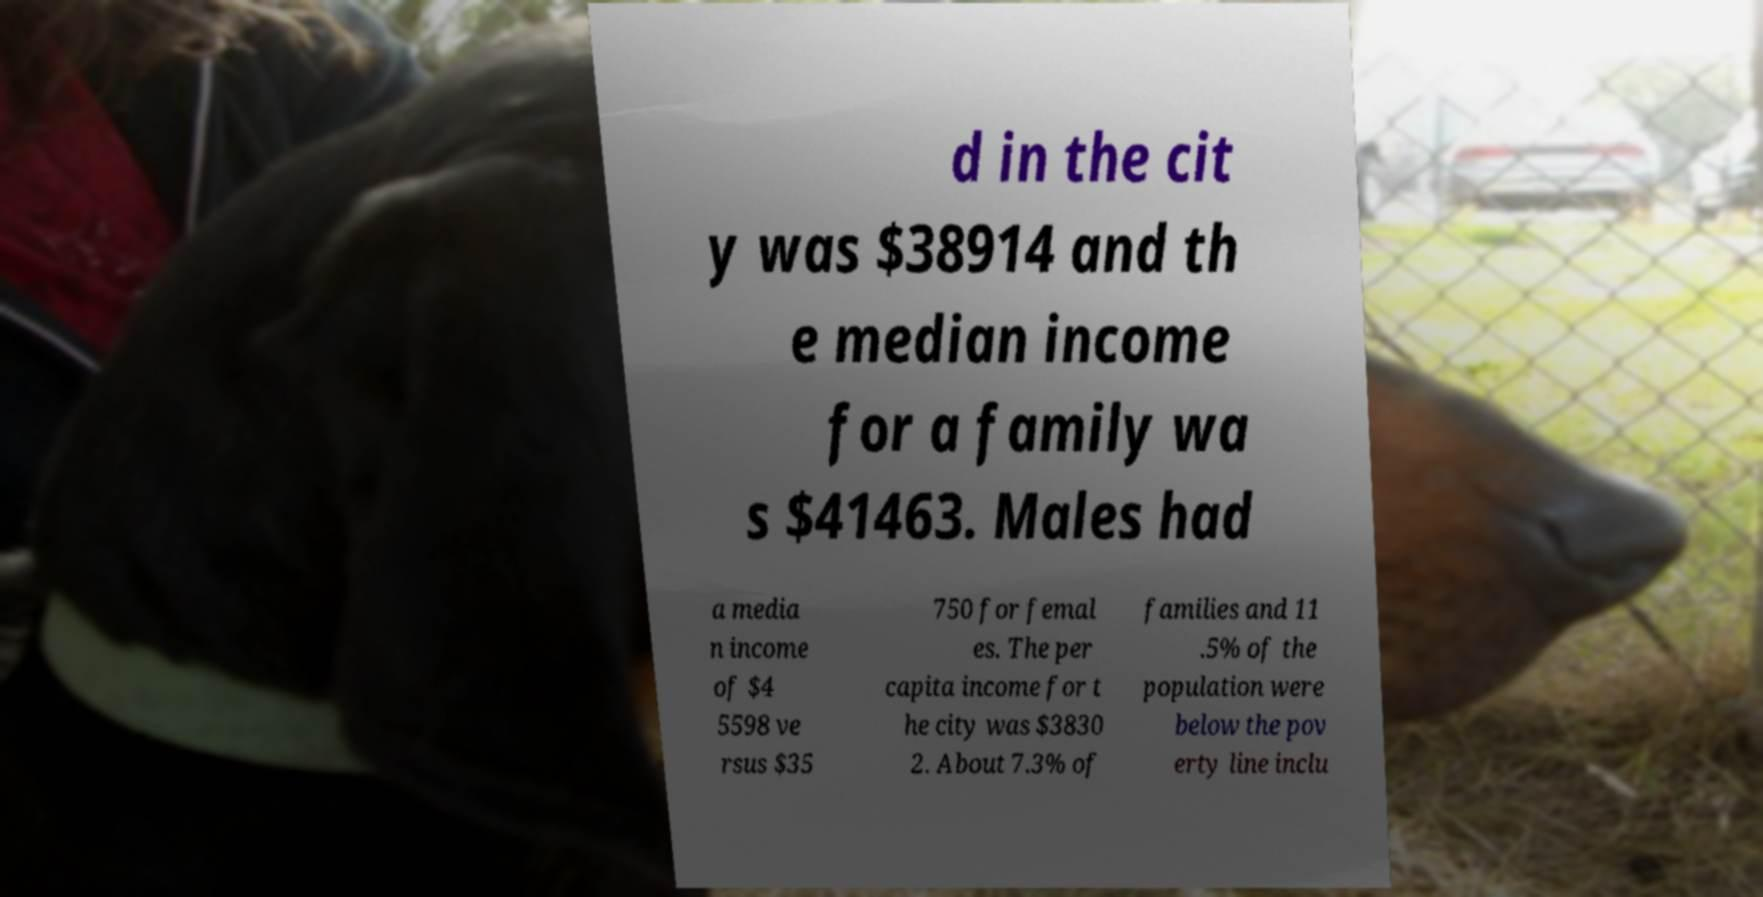Please identify and transcribe the text found in this image. d in the cit y was $38914 and th e median income for a family wa s $41463. Males had a media n income of $4 5598 ve rsus $35 750 for femal es. The per capita income for t he city was $3830 2. About 7.3% of families and 11 .5% of the population were below the pov erty line inclu 